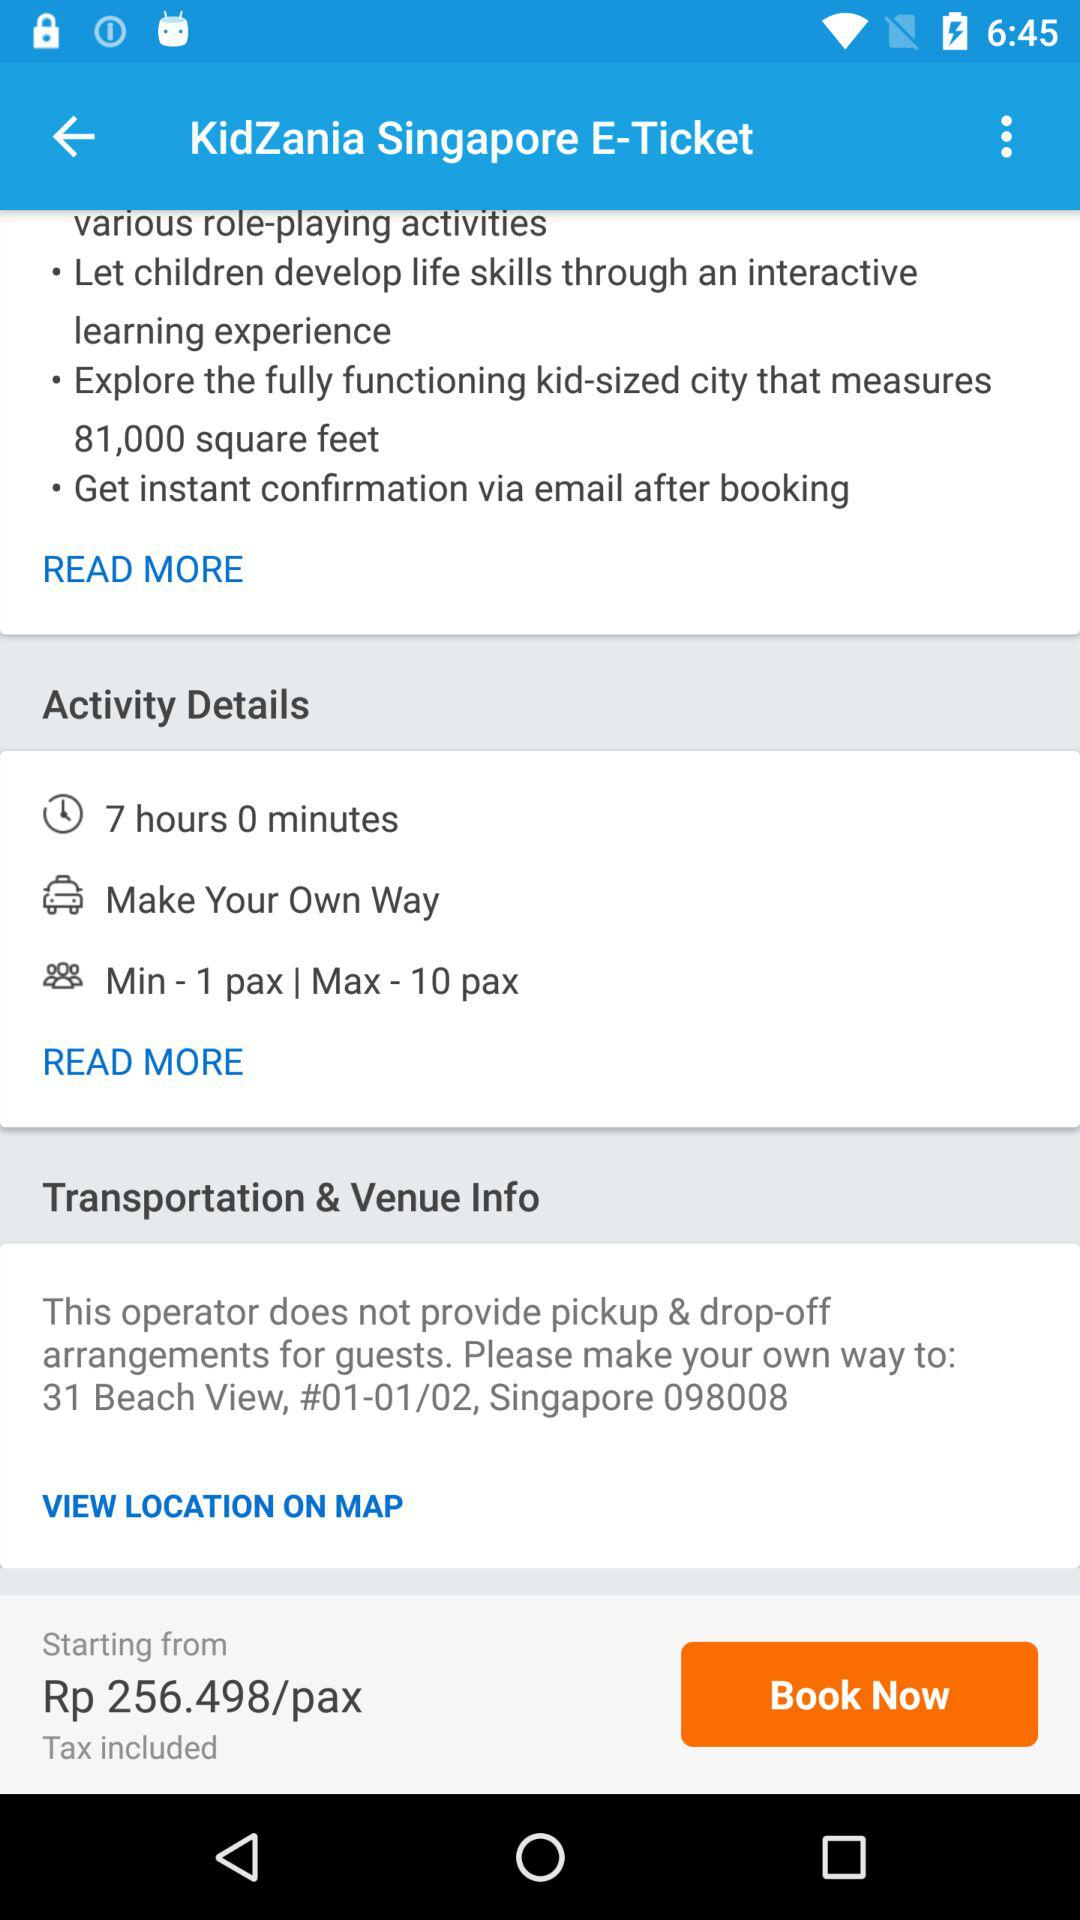How long is the activity?
Answer the question using a single word or phrase. 7 hours 0 minutes 